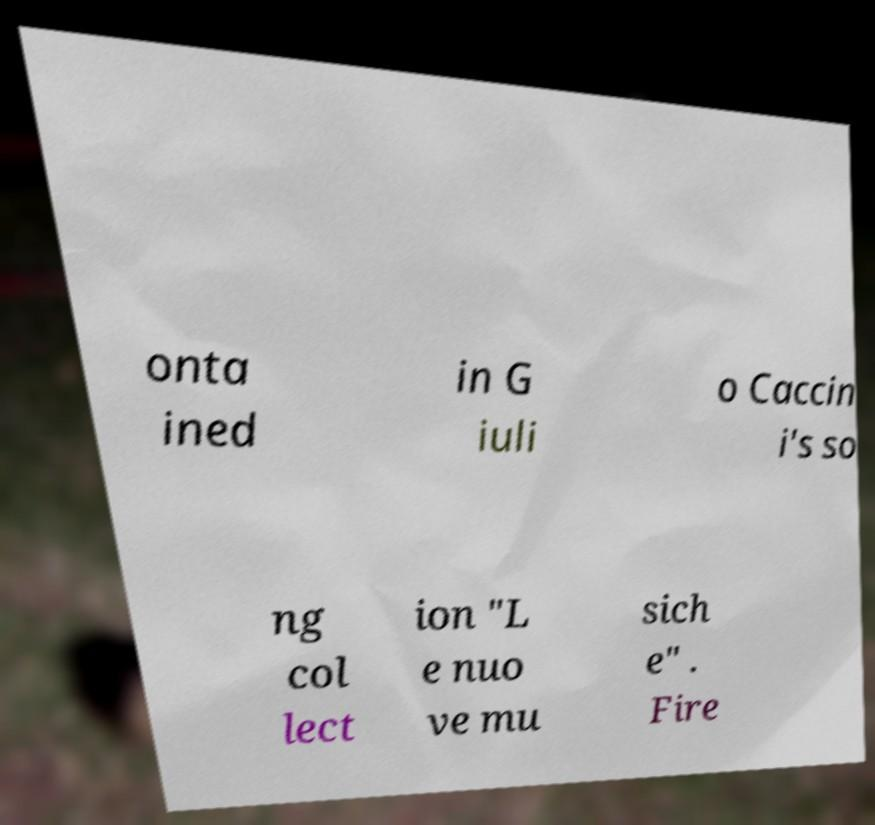For documentation purposes, I need the text within this image transcribed. Could you provide that? onta ined in G iuli o Caccin i's so ng col lect ion "L e nuo ve mu sich e" . Fire 